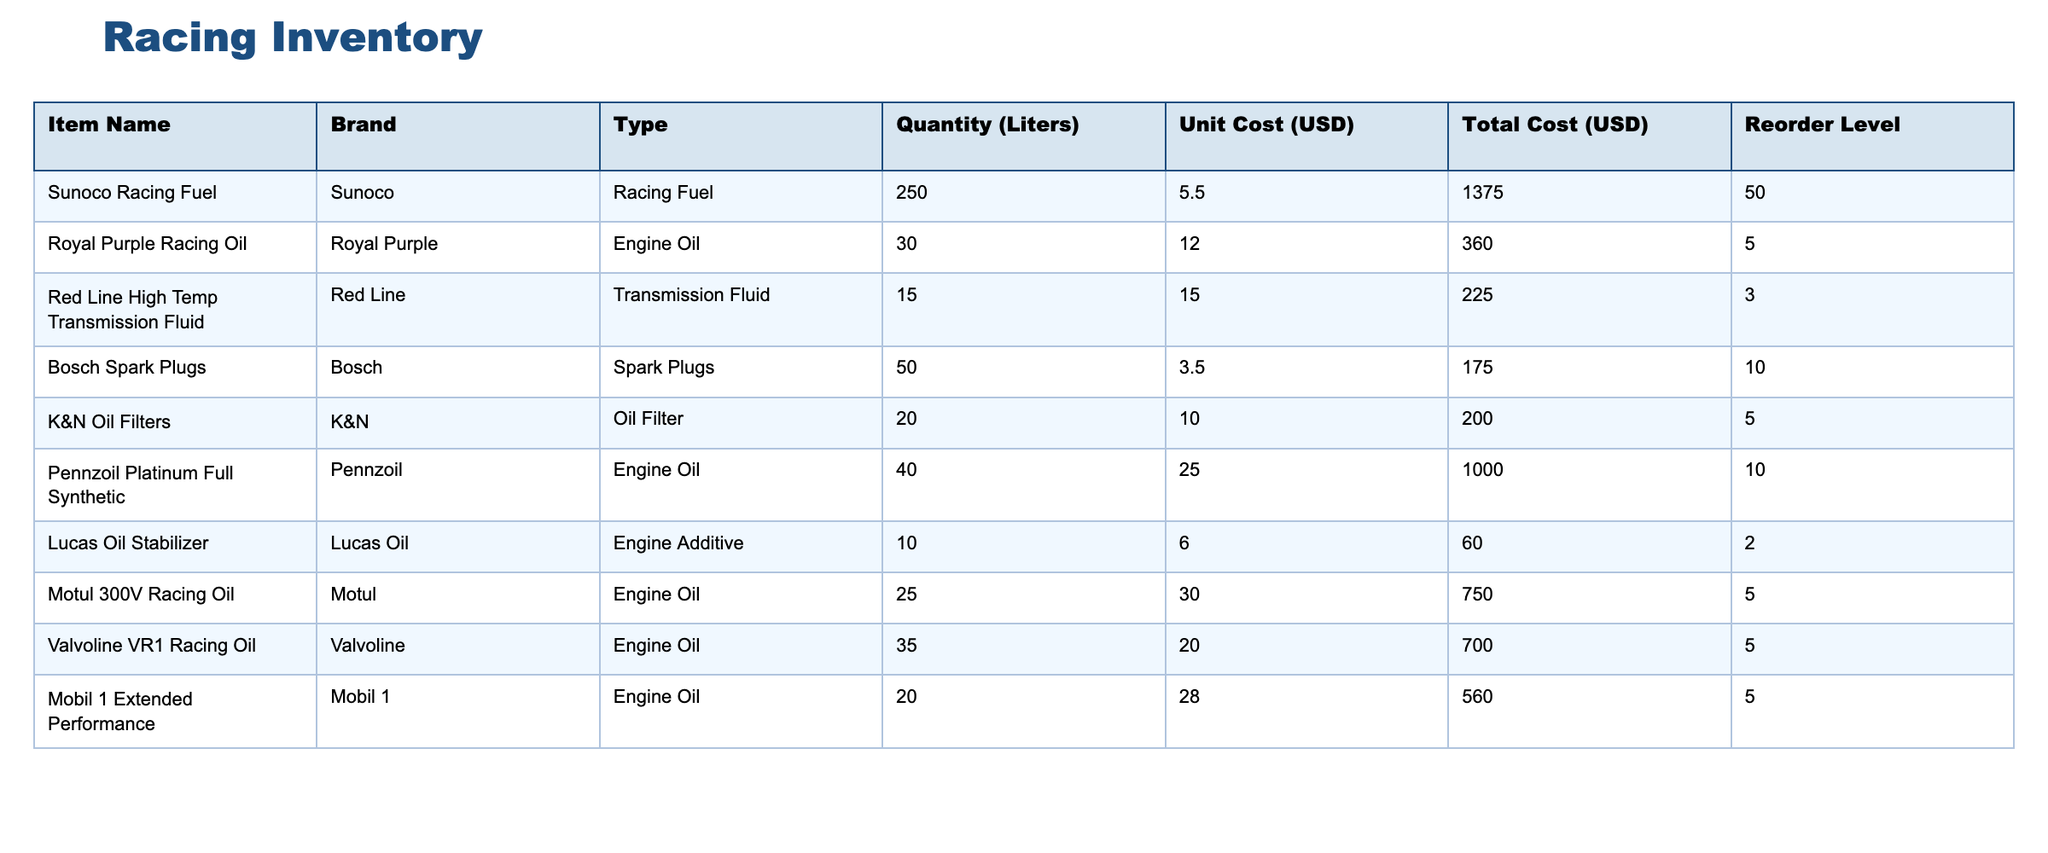What is the total cost of the Sunoco Racing Fuel? The total cost can be found by referring to the "Total Cost (USD)" column corresponding to "Sunoco Racing Fuel." The value listed is 1375.00 USD.
Answer: 1375.00 USD What is the reorder level for the Royal Purple Racing Oil? The reorder level is found in the "Reorder Level" column for "Royal Purple Racing Oil." The value listed is 5.
Answer: 5 What is the total quantity of Engine Oils in the inventory? To find the total quantity of Engine Oils, we sum the quantities from the relevant rows: Pennzoil (40) + Motul (25) + Valvoline (35) + Royal Purple (30) = 130 liters.
Answer: 130 liters Is the quantity of Red Line High Temp Transmission Fluid below its reorder level? The quantity for Red Line High Temp Transmission Fluid is 15 liters, and the reorder level is 3 liters. Since 15 is greater than 3, the answer is no.
Answer: No What is the average unit cost of all Engine Oils in the inventory? The unit costs for Engine Oils are: Royal Purple (12.00), Pennzoil (25.00), Motul (30.00), Valvoline (20.00), and Mobil 1 (28.00). The average is calculated as (12 + 25 + 30 + 20 + 28) / 5 = 125 / 5 = 25.
Answer: 25.00 How many items have a unit cost greater than 20 USD? We identify the items with unit costs greater than 20 USD: Pennzoil (25), Motul (30), Valvoline (20), and Mobil 1 (28), which totals 4 items.
Answer: 4 Which item has the highest total cost? We look at the "Total Cost (USD)" column and identify the maximum value, which is for Sunoco Racing Fuel at 1375.00 USD.
Answer: Sunoco Racing Fuel Is there any item that has a reorder level of 2 liters or below? By reviewing the "Reorder Level" column, we can see that Lucas Oil Stabilizer has a reorder level of 2 liters, so the answer is yes.
Answer: Yes What is the total cost of all items listed in the inventory? To find the total cost, sum all the total costs: 1375.00 + 360.00 + 225.00 + 175.00 + 200.00 + 1000.00 + 60.00 + 750.00 + 700.00 + 560.00 = 4755.00 USD.
Answer: 4755.00 USD 